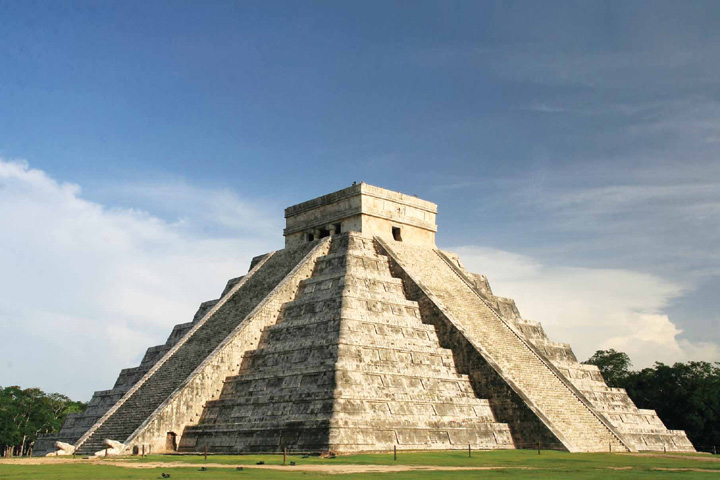What function did the temple at the top of the pyramid serve in Mayan culture? The temple atop the Chichen Itza pyramid was primarily used for ceremonial purposes and religious rituals. It was a sacred space where the Mayans performed offerings to their gods, particularly to Kukulcan, the feathered serpent deity. The strategic placement of the temple also indicates its significance in astronomical alignments and seasonal events. 